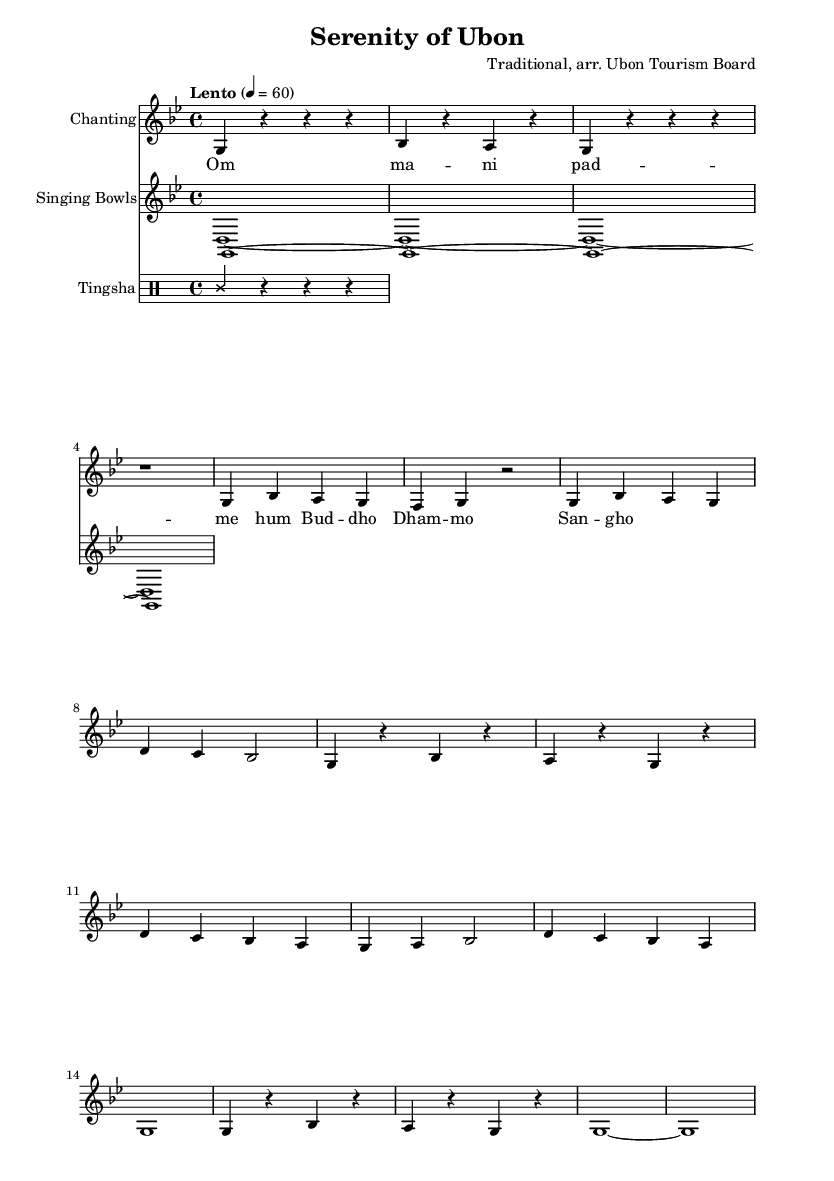What is the key signature of this music? The key signature displayed at the beginning of the music indicates that this piece is in G minor, which has two flats: B and E.
Answer: G minor What is the time signature of this music? The time signature indicated in the beginning of the score is 4/4, which means there are four beats per measure, and the quarter note gets one beat.
Answer: 4/4 What is the tempo marking of this piece? The tempo marking shows "Lento" with a metronome marking of 60, indicating that the piece should be played slowly at a speed of 60 beats per minute.
Answer: Lento 4 = 60 How many measures are in the chanting voice part? By counting the measures in the chanting voice part of the music, we can see that there are 16 measures total in this section.
Answer: 16 What is the main chant lyric used in this piece? The lyrics provided in the text correspond to traditional Buddhist chants "Om mani padme hum" and "Buddho Dhammo Sangho", indicating the central theme of the chanting.
Answer: Om mani padme hum Which instrument is responsible for the singing bowls? The sheet music clearly indicates a separate staff for the singing bowls, as shown in the instrumentation labels, identifying it in the performance.
Answer: Singing Bowls What visual marking indicates a resting note in the chant? The rest note is represented as a 'r' in the chanting voice part, showing instances where the voice is silent and allowing for moments of meditation.
Answer: r 